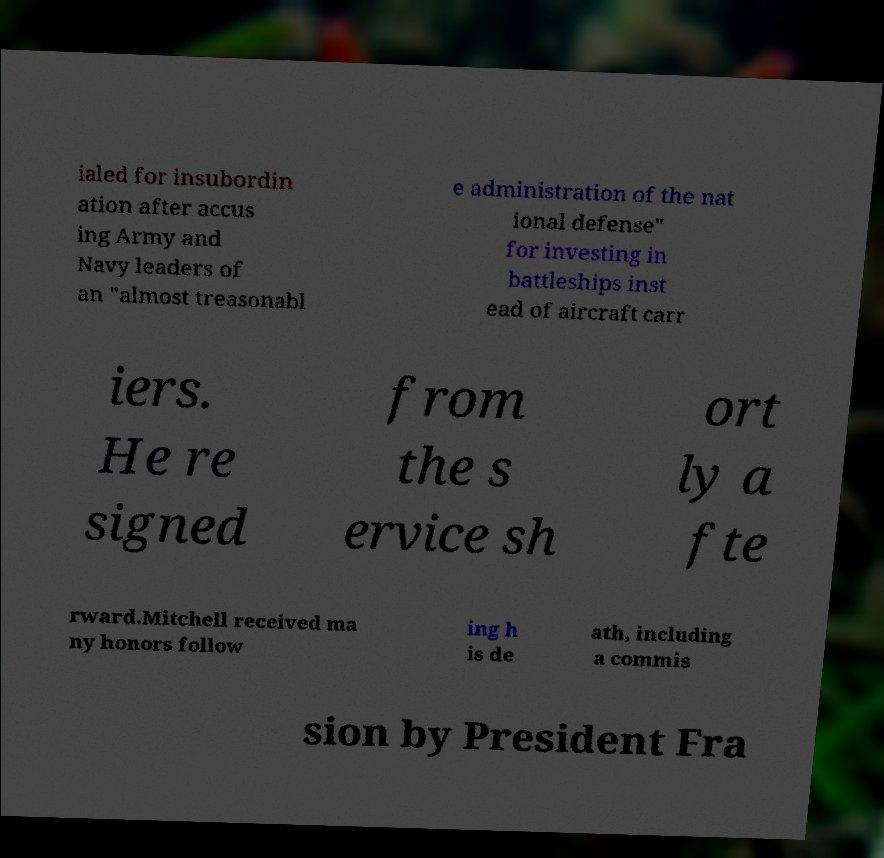I need the written content from this picture converted into text. Can you do that? ialed for insubordin ation after accus ing Army and Navy leaders of an "almost treasonabl e administration of the nat ional defense" for investing in battleships inst ead of aircraft carr iers. He re signed from the s ervice sh ort ly a fte rward.Mitchell received ma ny honors follow ing h is de ath, including a commis sion by President Fra 